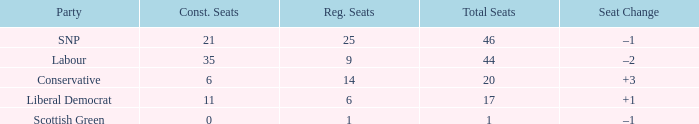What is the full number of Total Seats with a constituency seat number bigger than 0 with the Liberal Democrat party, and the Regional seat number is smaller than 6? None. 